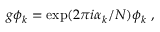<formula> <loc_0><loc_0><loc_500><loc_500>g \phi _ { k } = \exp ( 2 \pi i \alpha _ { k } / N ) \phi _ { k } ,</formula> 